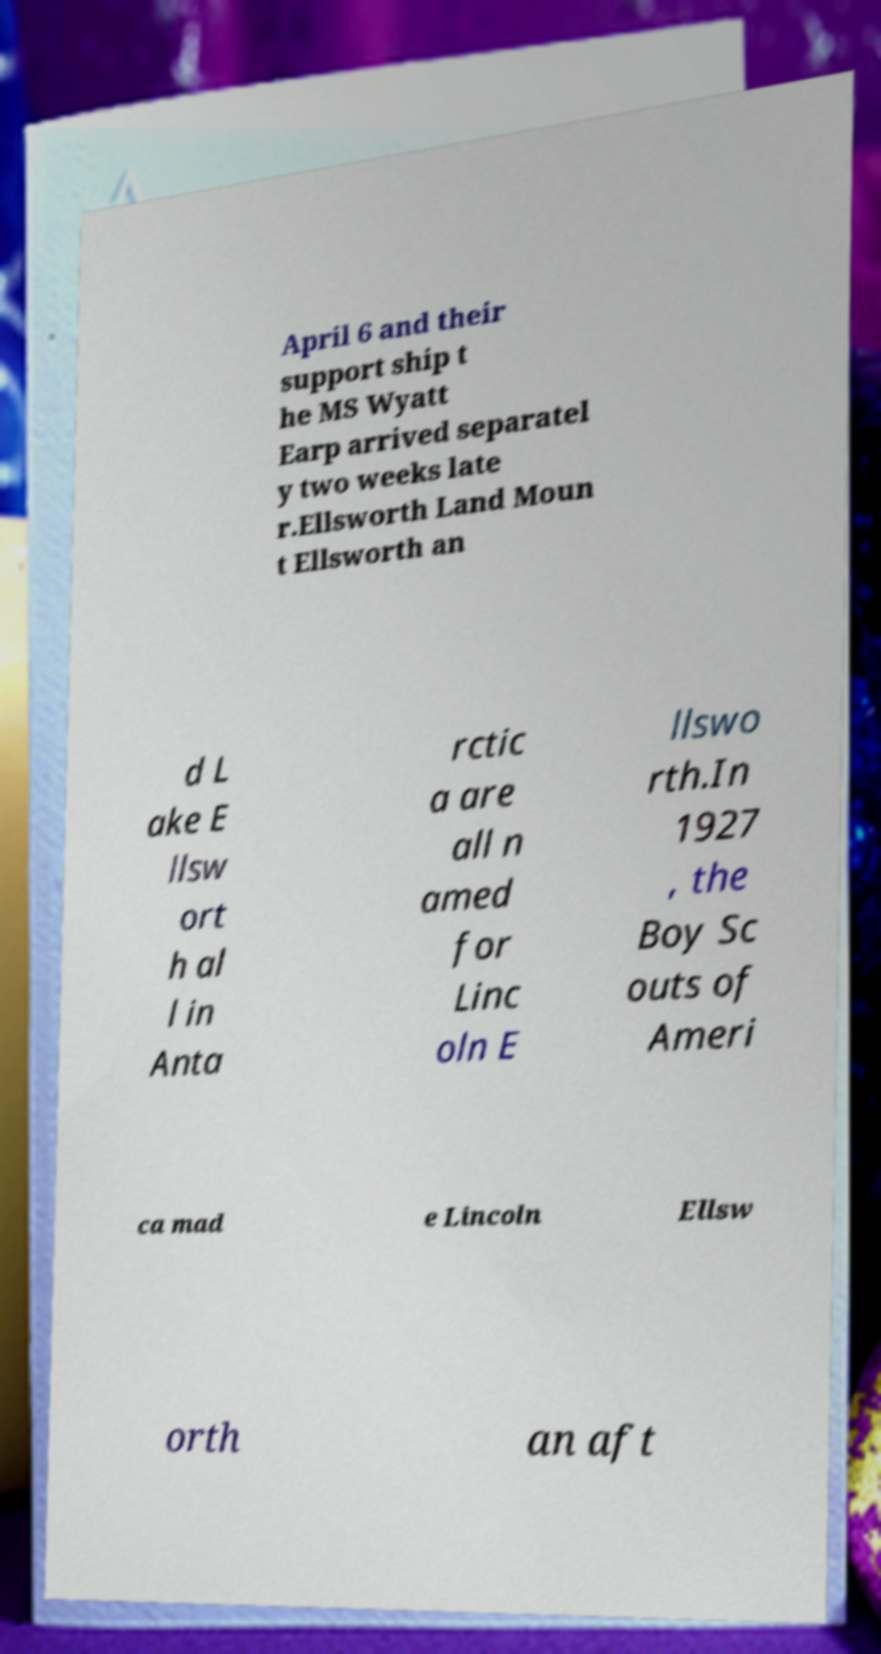I need the written content from this picture converted into text. Can you do that? April 6 and their support ship t he MS Wyatt Earp arrived separatel y two weeks late r.Ellsworth Land Moun t Ellsworth an d L ake E llsw ort h al l in Anta rctic a are all n amed for Linc oln E llswo rth.In 1927 , the Boy Sc outs of Ameri ca mad e Lincoln Ellsw orth an aft 